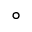Convert formula to latex. <formula><loc_0><loc_0><loc_500><loc_500>^ { \circ }</formula> 